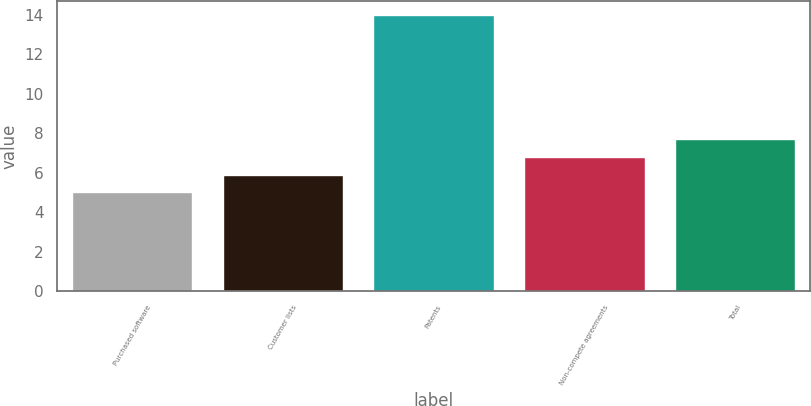Convert chart to OTSL. <chart><loc_0><loc_0><loc_500><loc_500><bar_chart><fcel>Purchased software<fcel>Customer lists<fcel>Patents<fcel>Non-compete agreements<fcel>Total<nl><fcel>5<fcel>5.9<fcel>14<fcel>6.8<fcel>7.7<nl></chart> 